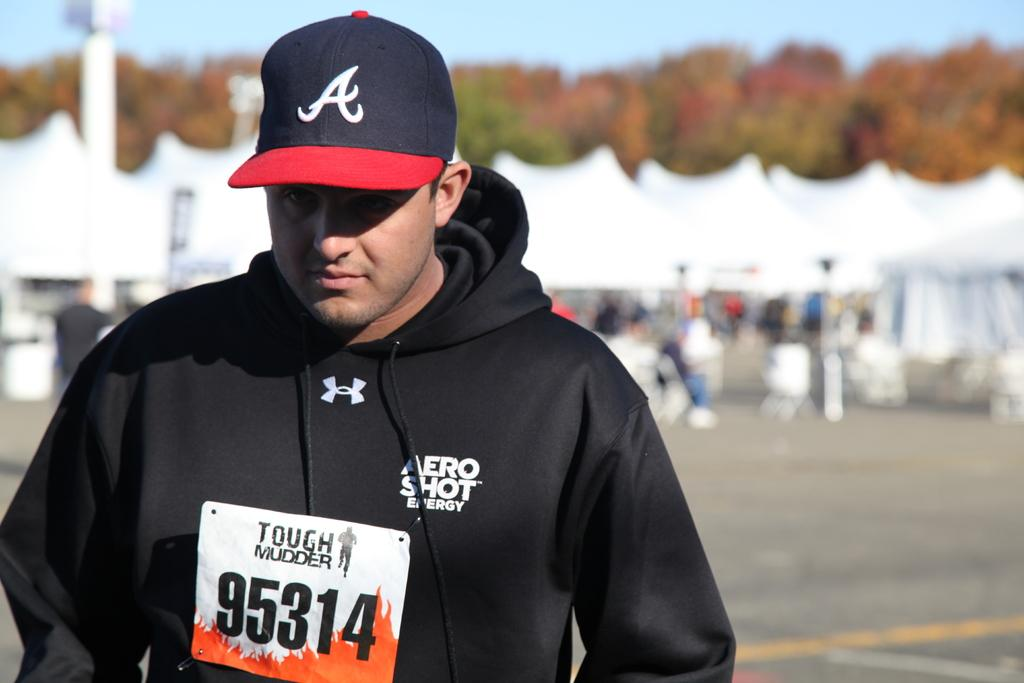Who or what is the main subject of the image? There is a person in the image. What is the person wearing? The person is wearing a black hoodie. What can be seen in the background of the image? There are trees and other objects in the background of the image. What type of blood is visible on the actor's face in the image? There is no actor or blood present in the image; it features a person wearing a black hoodie with trees and other objects in the background. 